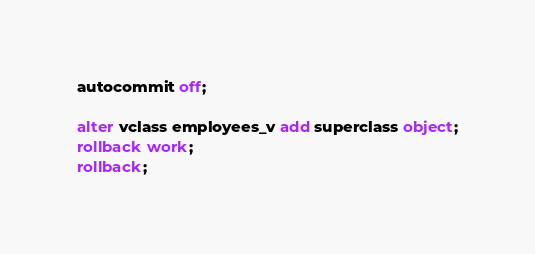Convert code to text. <code><loc_0><loc_0><loc_500><loc_500><_SQL_>autocommit off;

alter vclass employees_v add superclass object;
rollback work;
rollback;
</code> 